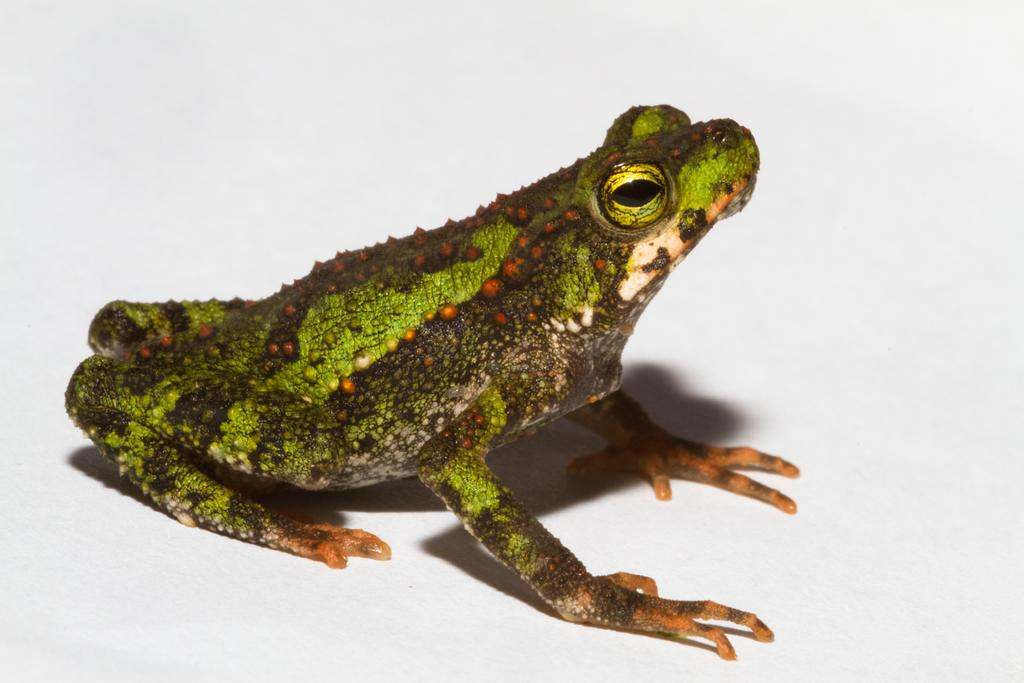What is the main subject of the image? There is a frog in the image. What color is the background of the image? The background of the image is white. Can you tell me how many vases are present in the image? There are no vases present in the image; it features a frog against a white background. What type of ear is visible in the image? There is no ear visible in the image; it features a frog against a white background. 